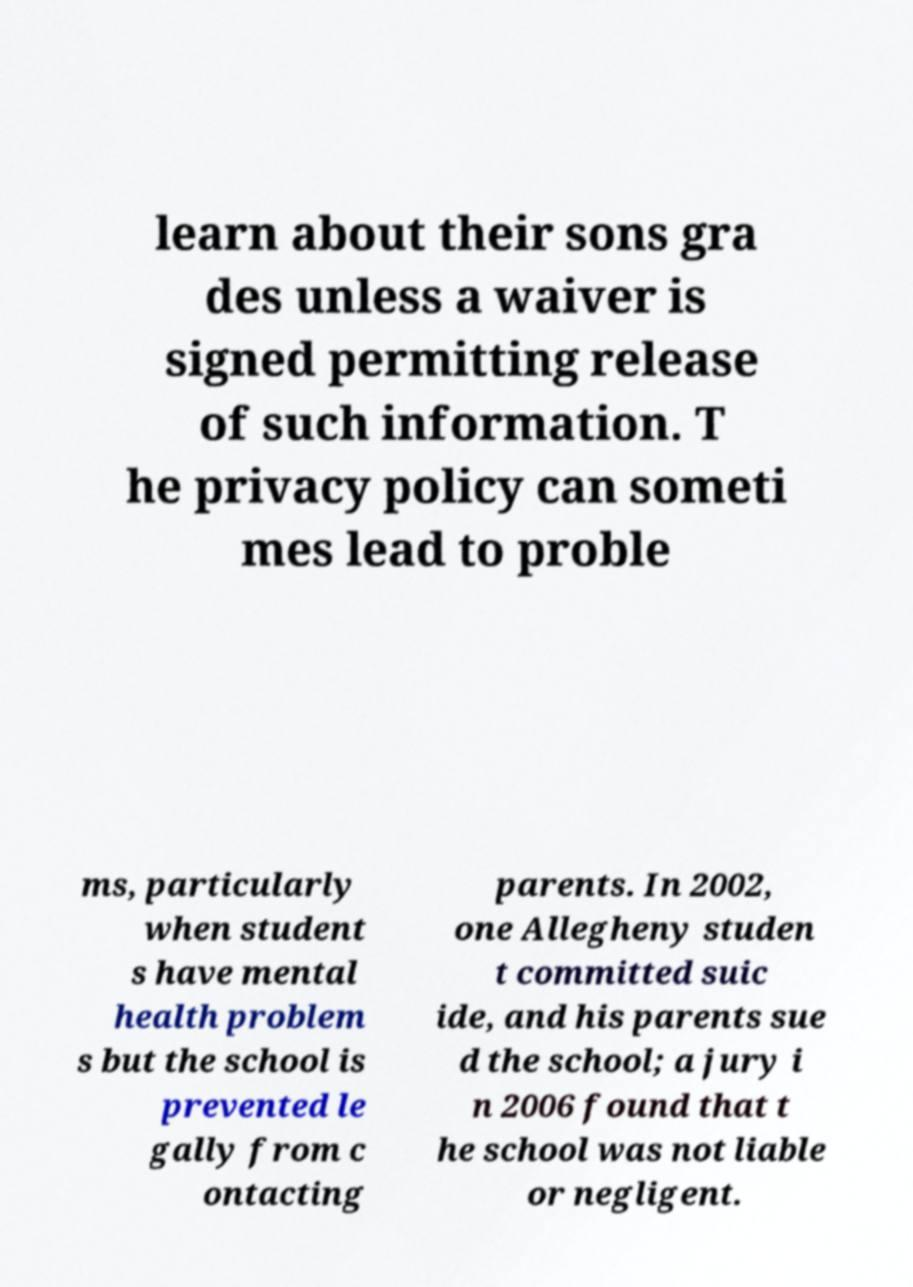Please identify and transcribe the text found in this image. learn about their sons gra des unless a waiver is signed permitting release of such information. T he privacy policy can someti mes lead to proble ms, particularly when student s have mental health problem s but the school is prevented le gally from c ontacting parents. In 2002, one Allegheny studen t committed suic ide, and his parents sue d the school; a jury i n 2006 found that t he school was not liable or negligent. 